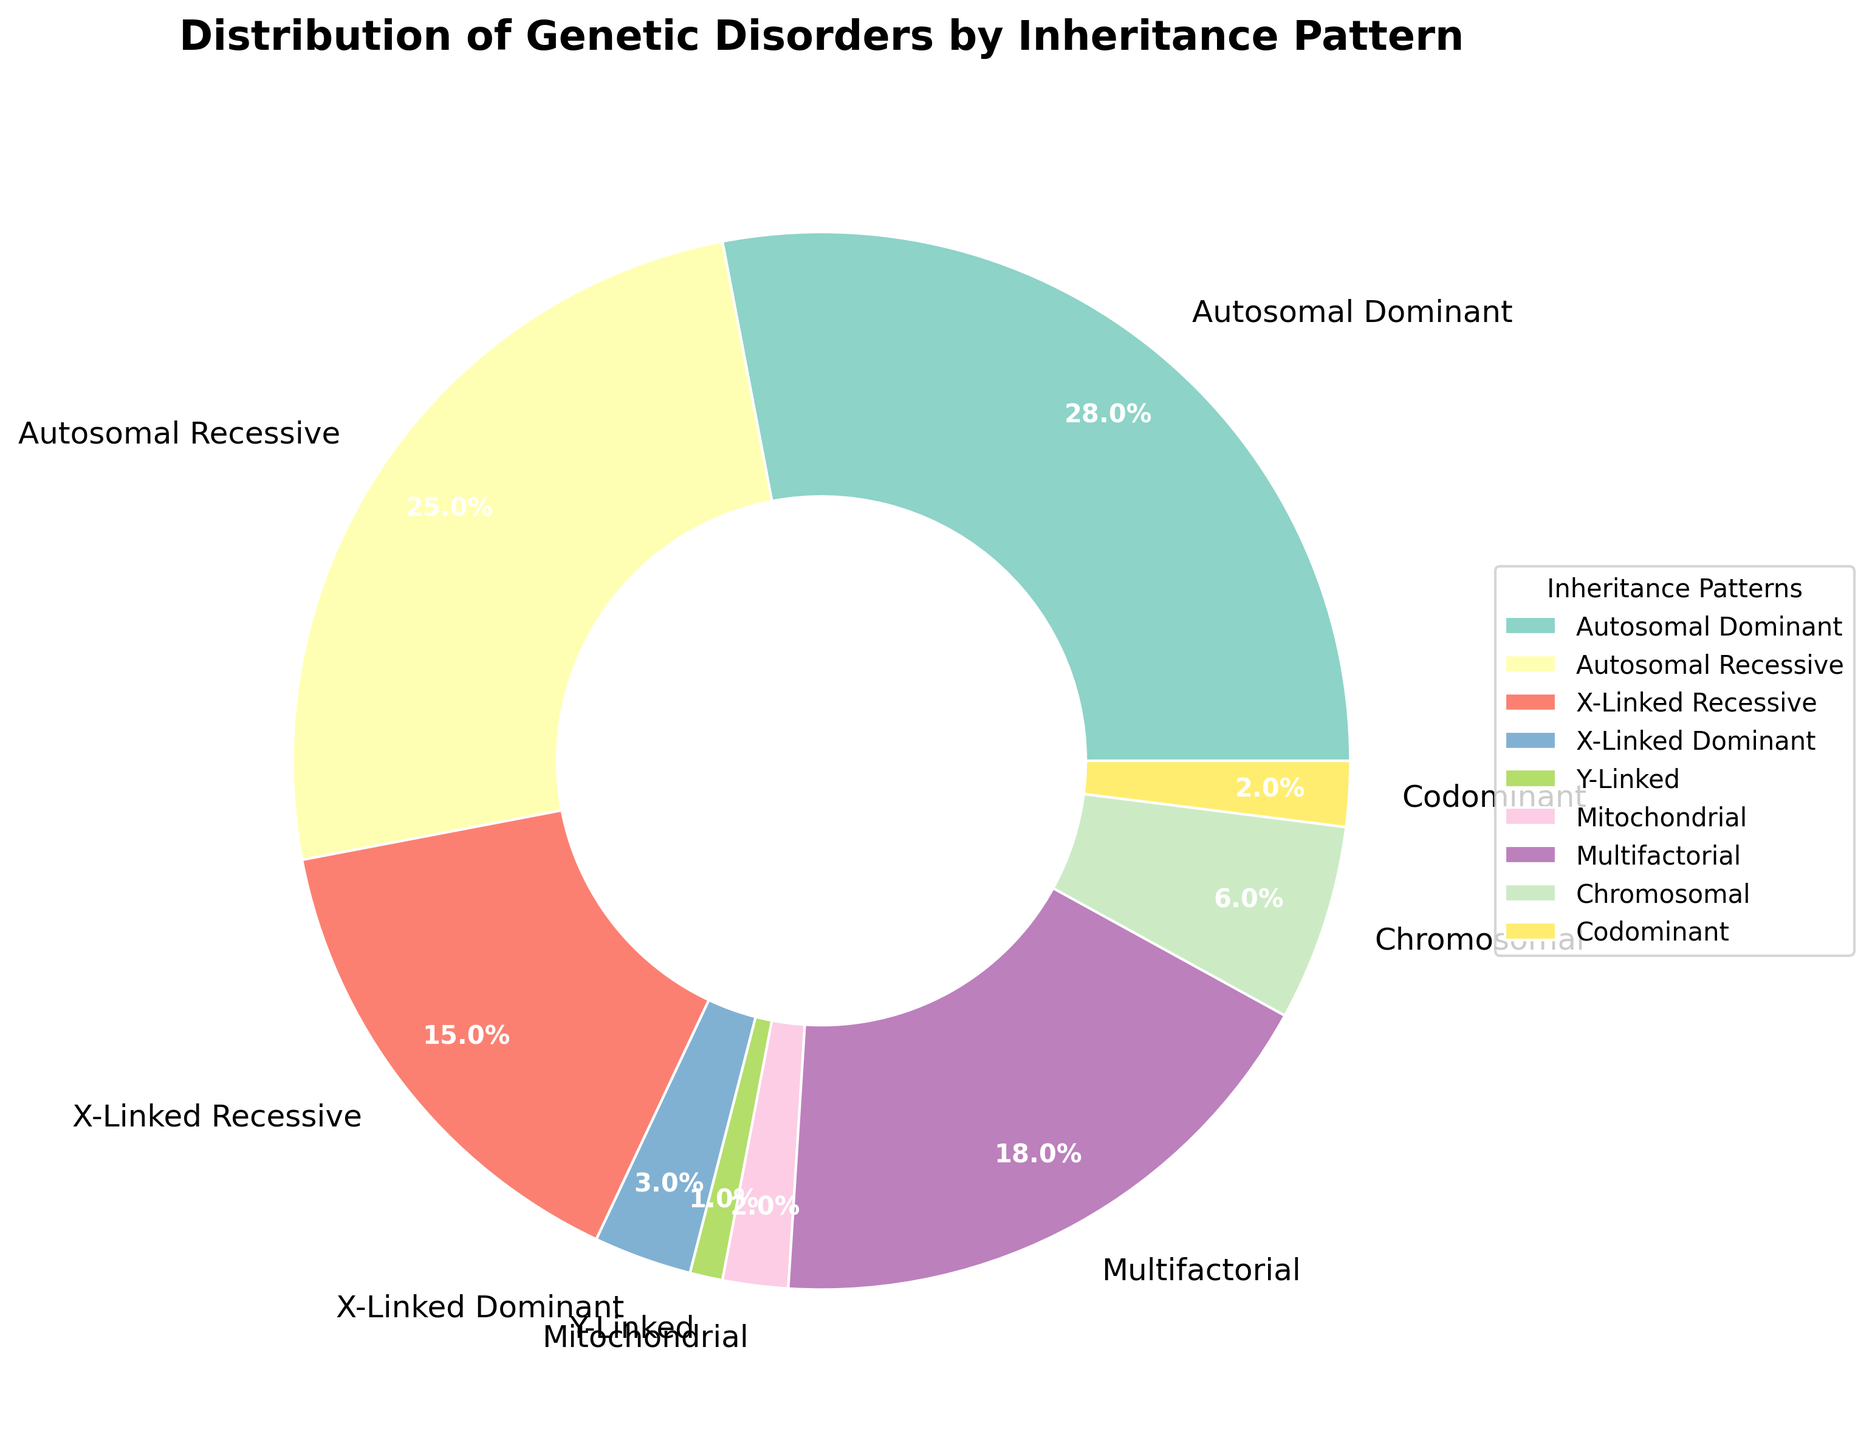Which inheritance pattern has the largest percentage? Look at the pie chart and identify the segment with the largest size. The largest segment is labeled "Autosomal Dominant" with a percentage of 28%.
Answer: Autosomal Dominant Which two inheritance patterns have the smallest percentages? Identify the two smallest segments in the pie chart. The smallest segments are "Y-Linked" (1%) and "Mitochondrial" (2%) or "Codominant" (2%).
Answer: Y-Linked and (Mitochondrial or Codominant) What is the combined percentage of Autosomal Dominant and Autosomal Recessive disorders? Add the percentages for Autosomal Dominant (28%) and Autosomal Recessive (25%). The combined percentage is 28% + 25% = 53%.
Answer: 53% How does the percentage of X-Linked Recessive disorders compare to the percentage of Multifactorial disorders? Compare the sizes of the pie segments labeled "X-Linked Recessive" (15%) and "Multifactorial" (18%). The "Multifactorial" segment is larger.
Answer: Multifactorial is larger What is the largest difference in percentage between any two inheritance patterns? Calculate differences between all pairs of percentages. The largest difference is between Autosomal Dominant (28%) and Y-Linked (1%), which is 28% - 1% = 27%.
Answer: 27% What percentage of genetic disorders have an X-linked inheritance pattern (combining X-Linked Dominant and X-Linked Recessive)? Add the percentages for X-Linked Recessive (15%) and X-Linked Dominant (3%). The total is 15% + 3% = 18%.
Answer: 18% What percentage of genetic disorders are neither Autosomal nor X-Linked? Sum the percentages for Y-Linked (1%), Mitochondrial (2%), Multifactorial (18%), Chromosomal (6%), and Codominant (2%). The combined percentage is 1% + 2% + 18% + 6% + 2% = 29%.
Answer: 29% What is the average percentage of Chromosomal, Mitochondrial, and Codominant disorders? Add the percentages for Chromosomal (6%), Mitochondrial (2%), and Codominant (2%), then divide by 3. The average is (6% + 2% + 2%) / 3 = 3.33%.
Answer: 3.33% Is the percentage of Multifactorial disorders more than double the percentage of Autosomal Recessive disorders? Compare the percentage of Multifactorial (18%) to double the percentage of Autosomal Recessive (25% * 2 = 50%). 18% is not more than 50%.
Answer: No Which inheritance pattern has approximately half the percentage of Autosomal Recessive disorders? Identify the inheritance pattern with a percentage close to half of 25%, which is 12.5%. The closest percentage is X-Linked Recessive (15%).
Answer: X-Linked Recessive 